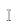Convert formula to latex. <formula><loc_0><loc_0><loc_500><loc_500>\mathbb { I }</formula> 